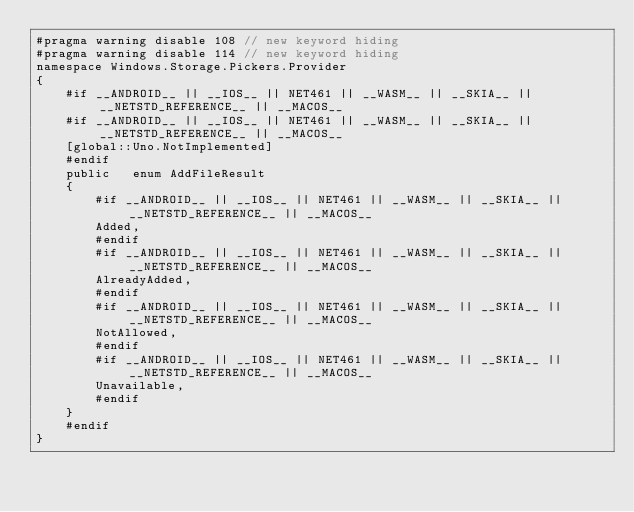Convert code to text. <code><loc_0><loc_0><loc_500><loc_500><_C#_>#pragma warning disable 108 // new keyword hiding
#pragma warning disable 114 // new keyword hiding
namespace Windows.Storage.Pickers.Provider
{
	#if __ANDROID__ || __IOS__ || NET461 || __WASM__ || __SKIA__ || __NETSTD_REFERENCE__ || __MACOS__
	#if __ANDROID__ || __IOS__ || NET461 || __WASM__ || __SKIA__ || __NETSTD_REFERENCE__ || __MACOS__
	[global::Uno.NotImplemented]
	#endif
	public   enum AddFileResult 
	{
		#if __ANDROID__ || __IOS__ || NET461 || __WASM__ || __SKIA__ || __NETSTD_REFERENCE__ || __MACOS__
		Added,
		#endif
		#if __ANDROID__ || __IOS__ || NET461 || __WASM__ || __SKIA__ || __NETSTD_REFERENCE__ || __MACOS__
		AlreadyAdded,
		#endif
		#if __ANDROID__ || __IOS__ || NET461 || __WASM__ || __SKIA__ || __NETSTD_REFERENCE__ || __MACOS__
		NotAllowed,
		#endif
		#if __ANDROID__ || __IOS__ || NET461 || __WASM__ || __SKIA__ || __NETSTD_REFERENCE__ || __MACOS__
		Unavailable,
		#endif
	}
	#endif
}
</code> 